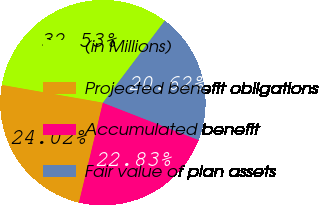Convert chart. <chart><loc_0><loc_0><loc_500><loc_500><pie_chart><fcel>(in Millions)<fcel>Projected benefit obligations<fcel>Accumulated benefit<fcel>Fair value of plan assets<nl><fcel>32.53%<fcel>24.02%<fcel>22.83%<fcel>20.62%<nl></chart> 